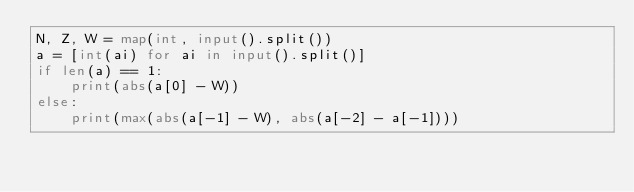<code> <loc_0><loc_0><loc_500><loc_500><_Python_>N, Z, W = map(int, input().split())
a = [int(ai) for ai in input().split()]
if len(a) == 1:
    print(abs(a[0] - W))
else:
    print(max(abs(a[-1] - W), abs(a[-2] - a[-1])))</code> 